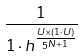Convert formula to latex. <formula><loc_0><loc_0><loc_500><loc_500>\frac { 1 } { 1 \cdot h ^ { \frac { U \times ( 1 \cdot U ) } { 5 ^ { N + 1 } } } }</formula> 